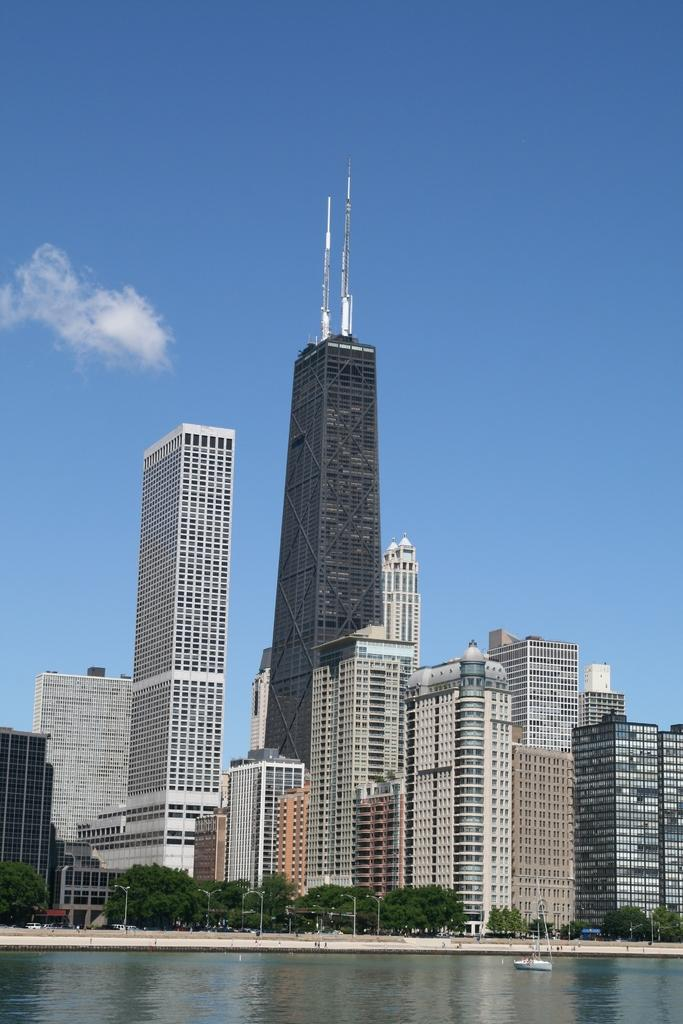What is the main subject of the image? The main subject of the image is a boat. Where is the boat located? The boat is on the water. What can be seen in the background of the image? In the background of the image, there are poles, trees, buildings, objects on the building, and clouds in the sky. What type of leather can be seen on the boat in the image? There is no leather visible on the boat in the image. Can you describe the flight of the birds in the image? There are no birds present in the image, so it is not possible to describe their flight. 